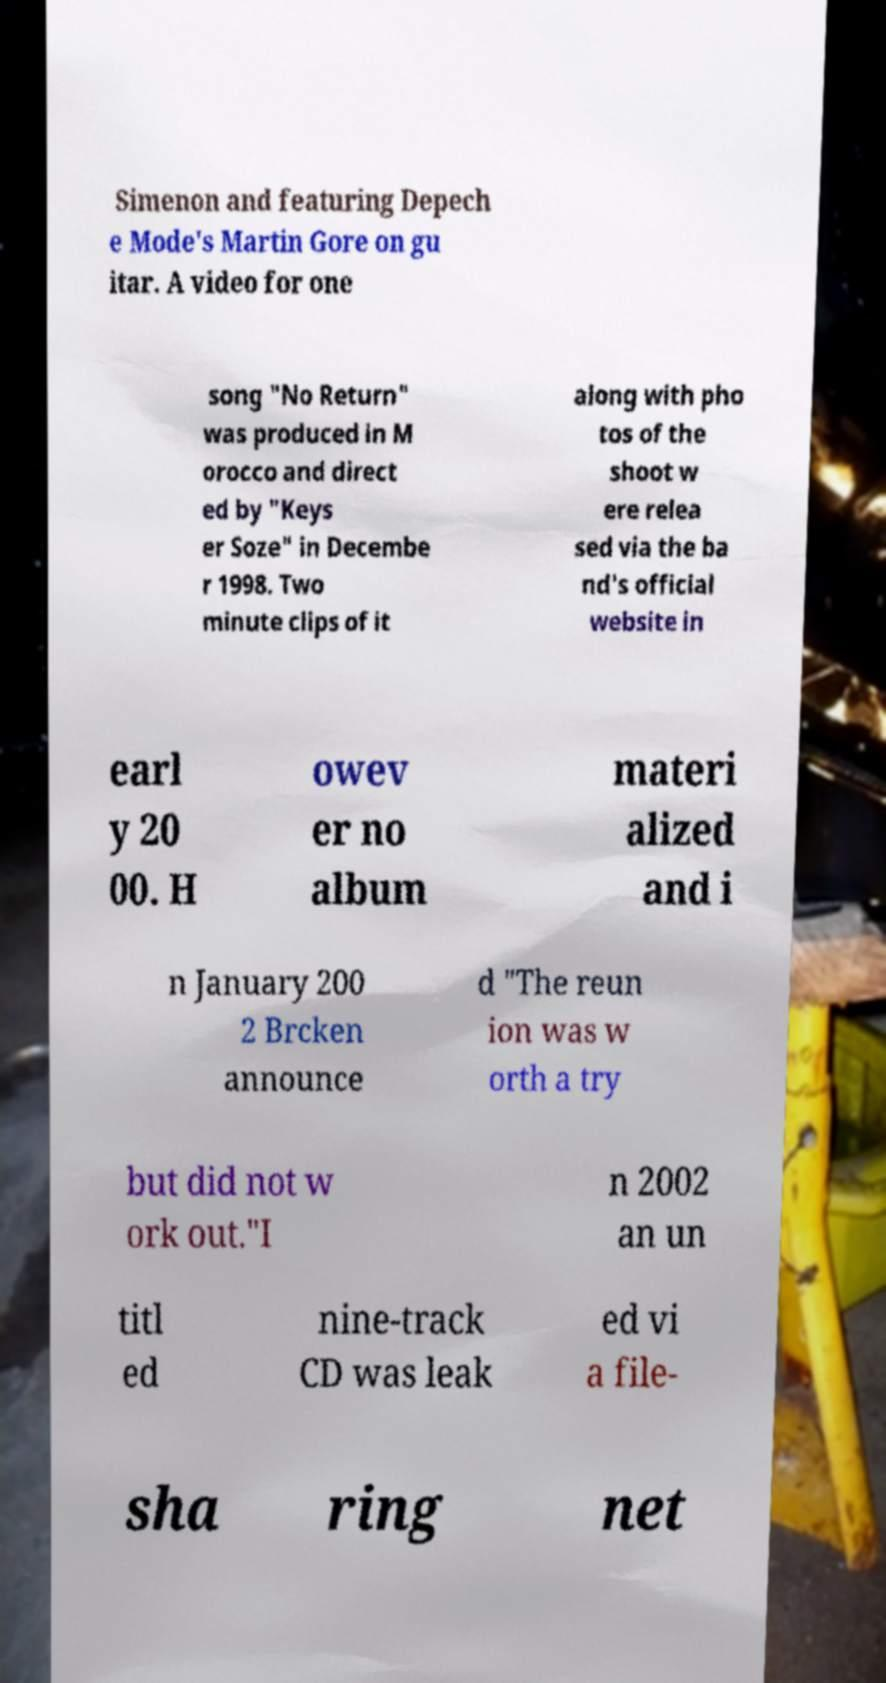Could you assist in decoding the text presented in this image and type it out clearly? Simenon and featuring Depech e Mode's Martin Gore on gu itar. A video for one song "No Return" was produced in M orocco and direct ed by "Keys er Soze" in Decembe r 1998. Two minute clips of it along with pho tos of the shoot w ere relea sed via the ba nd's official website in earl y 20 00. H owev er no album materi alized and i n January 200 2 Brcken announce d "The reun ion was w orth a try but did not w ork out."I n 2002 an un titl ed nine-track CD was leak ed vi a file- sha ring net 